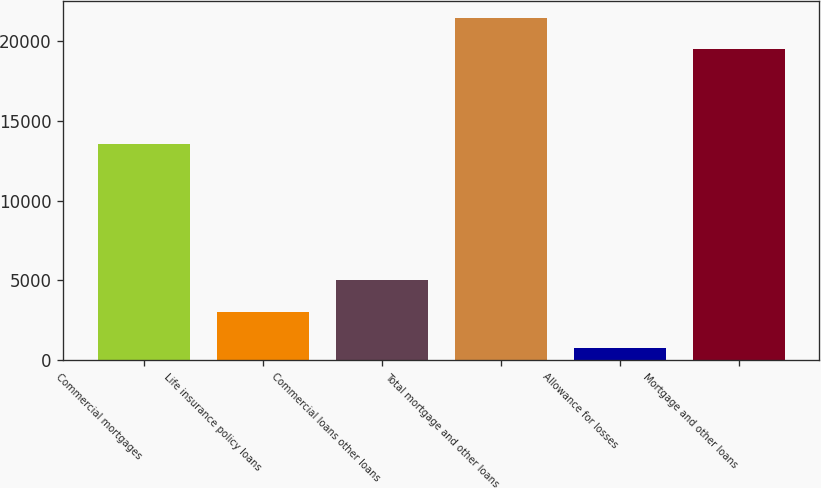Convert chart to OTSL. <chart><loc_0><loc_0><loc_500><loc_500><bar_chart><fcel>Commercial mortgages<fcel>Life insurance policy loans<fcel>Commercial loans other loans<fcel>Total mortgage and other loans<fcel>Allowance for losses<fcel>Mortgage and other loans<nl><fcel>13554<fcel>3049<fcel>4997.9<fcel>21437.9<fcel>740<fcel>19489<nl></chart> 